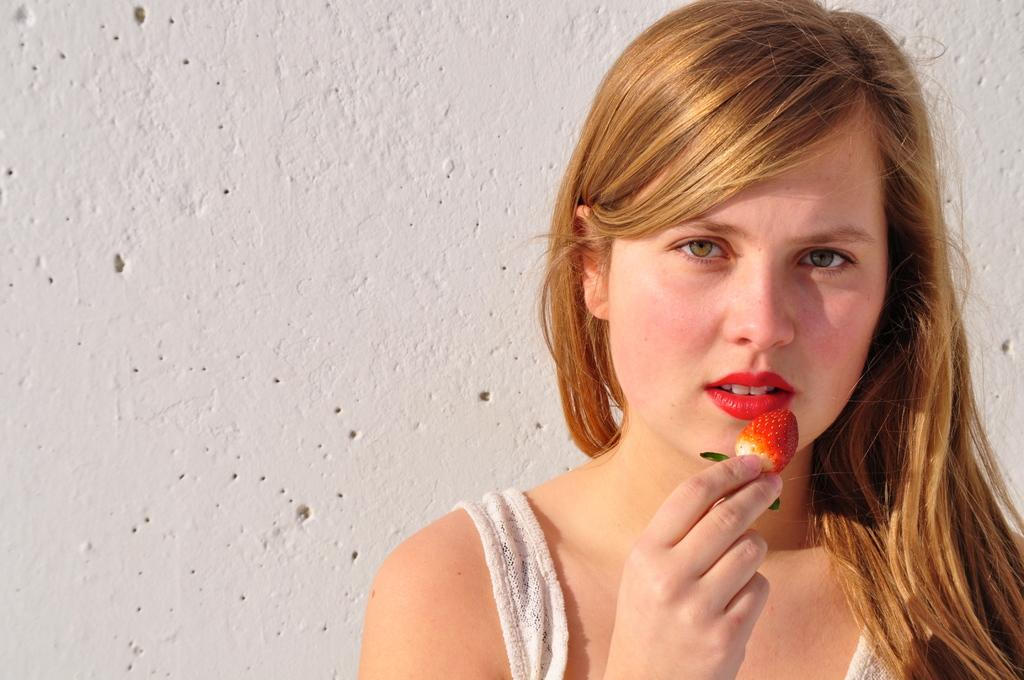Who is present in the image? There is a woman in the image. What is the woman holding in her hand? The woman is holding a strawberry in her hand. What can be seen behind the woman in the image? There is a wall in the image. What is the color of the wall? The wall is white in color. What type of cable is being used by the porter in the image? There is no porter or cable present in the image. How many eggs are visible in the image? There are no eggs visible in the image. 